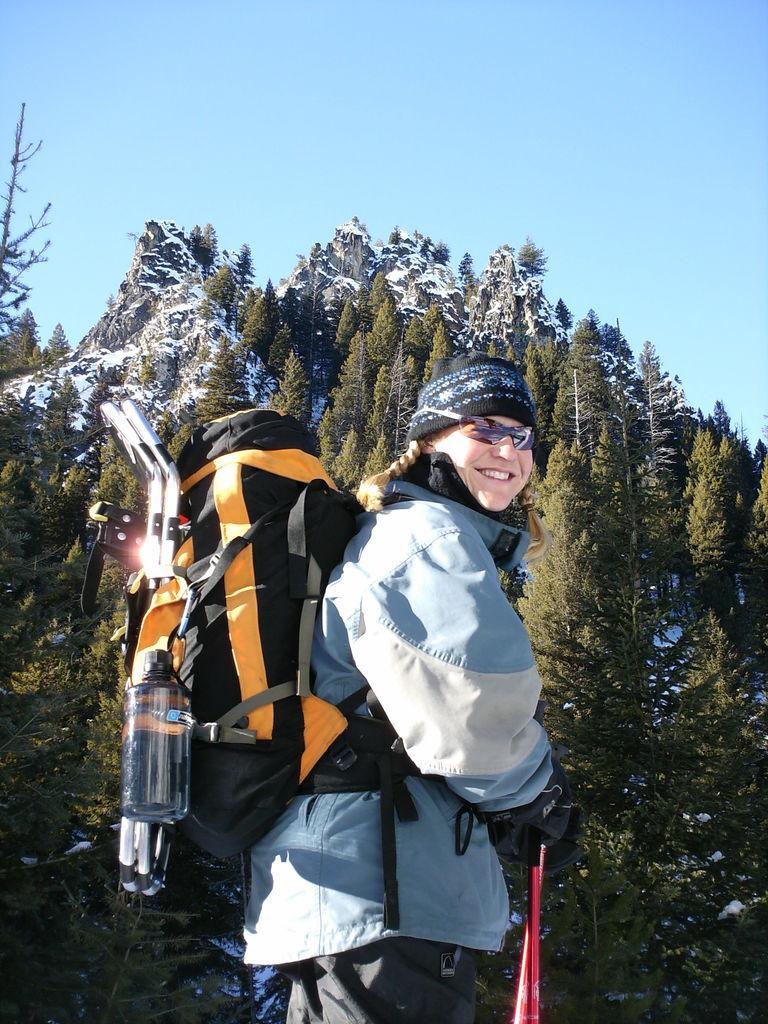Please provide a concise description of this image. This image is taken outdoors. At the top of the image there is the sky. In the background there are a few hills covered with snow and there are many trees with leaves, stems and branches. In the middle of the image a person is standing and she is holding ski sticks in her hands and she has worn a cap and a backpack. There is a bottle. 